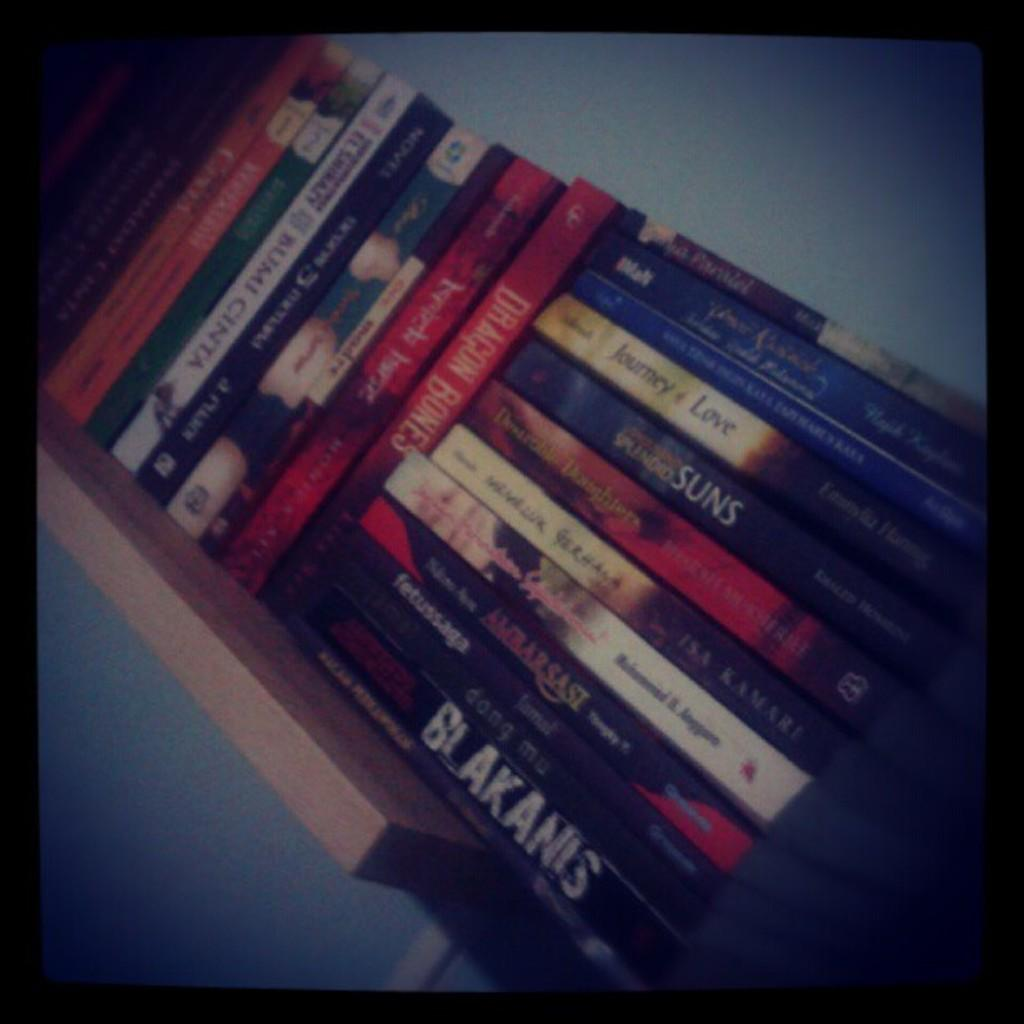<image>
Provide a brief description of the given image. A shelf with a bunch of books has one on it titled Blakanis. 